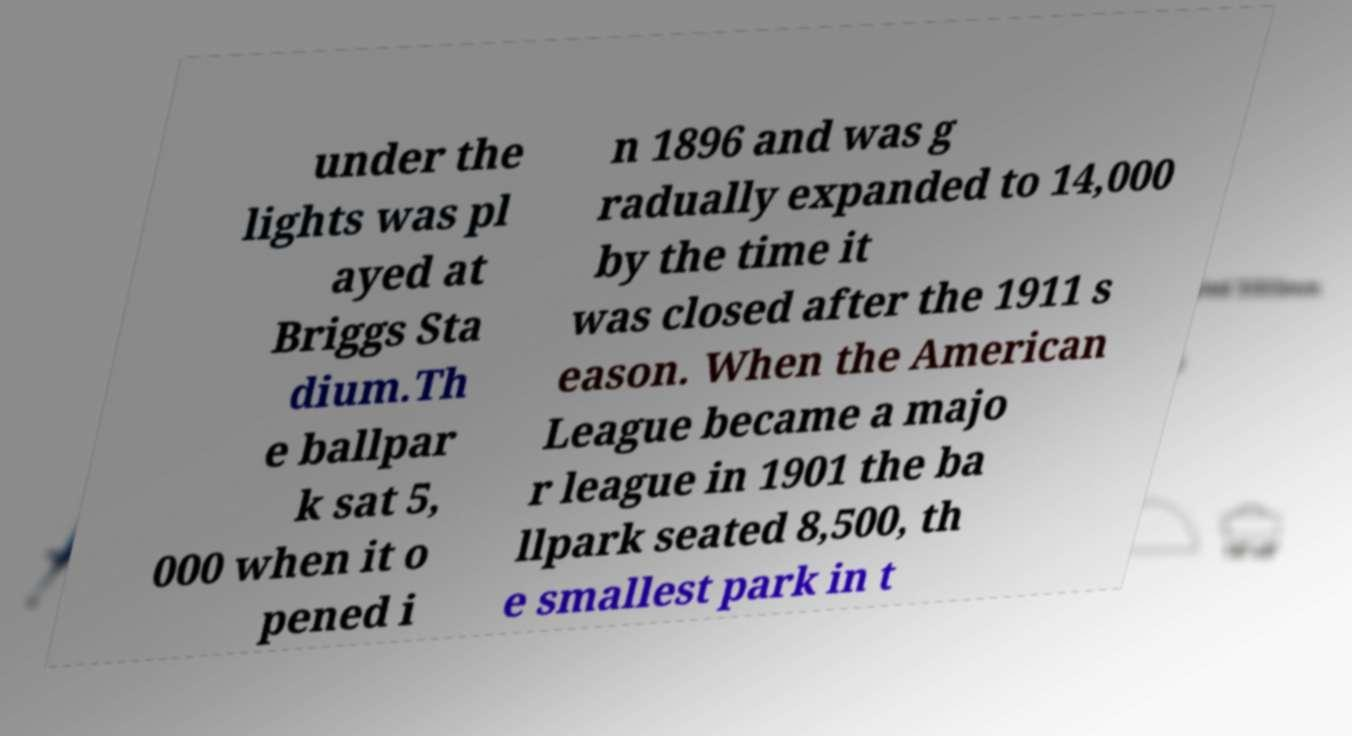For documentation purposes, I need the text within this image transcribed. Could you provide that? under the lights was pl ayed at Briggs Sta dium.Th e ballpar k sat 5, 000 when it o pened i n 1896 and was g radually expanded to 14,000 by the time it was closed after the 1911 s eason. When the American League became a majo r league in 1901 the ba llpark seated 8,500, th e smallest park in t 